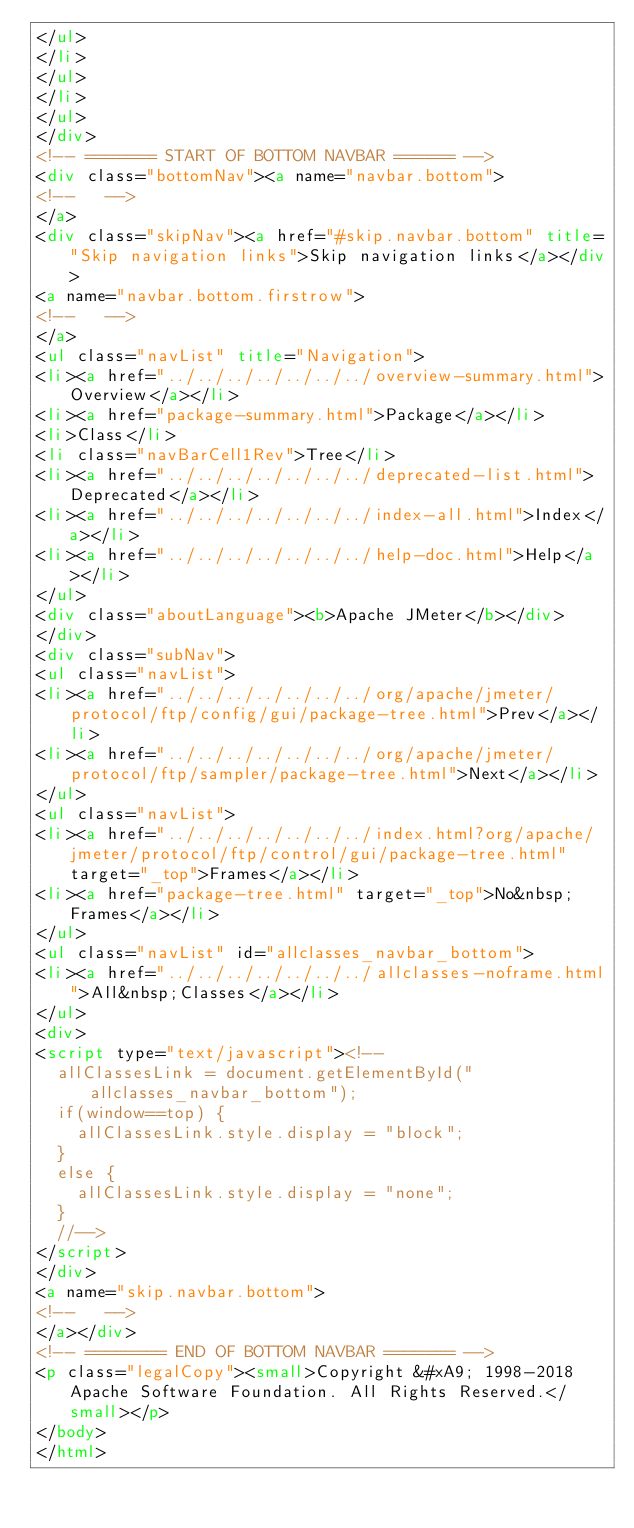<code> <loc_0><loc_0><loc_500><loc_500><_HTML_></ul>
</li>
</ul>
</li>
</ul>
</div>
<!-- ======= START OF BOTTOM NAVBAR ====== -->
<div class="bottomNav"><a name="navbar.bottom">
<!--   -->
</a>
<div class="skipNav"><a href="#skip.navbar.bottom" title="Skip navigation links">Skip navigation links</a></div>
<a name="navbar.bottom.firstrow">
<!--   -->
</a>
<ul class="navList" title="Navigation">
<li><a href="../../../../../../../overview-summary.html">Overview</a></li>
<li><a href="package-summary.html">Package</a></li>
<li>Class</li>
<li class="navBarCell1Rev">Tree</li>
<li><a href="../../../../../../../deprecated-list.html">Deprecated</a></li>
<li><a href="../../../../../../../index-all.html">Index</a></li>
<li><a href="../../../../../../../help-doc.html">Help</a></li>
</ul>
<div class="aboutLanguage"><b>Apache JMeter</b></div>
</div>
<div class="subNav">
<ul class="navList">
<li><a href="../../../../../../../org/apache/jmeter/protocol/ftp/config/gui/package-tree.html">Prev</a></li>
<li><a href="../../../../../../../org/apache/jmeter/protocol/ftp/sampler/package-tree.html">Next</a></li>
</ul>
<ul class="navList">
<li><a href="../../../../../../../index.html?org/apache/jmeter/protocol/ftp/control/gui/package-tree.html" target="_top">Frames</a></li>
<li><a href="package-tree.html" target="_top">No&nbsp;Frames</a></li>
</ul>
<ul class="navList" id="allclasses_navbar_bottom">
<li><a href="../../../../../../../allclasses-noframe.html">All&nbsp;Classes</a></li>
</ul>
<div>
<script type="text/javascript"><!--
  allClassesLink = document.getElementById("allclasses_navbar_bottom");
  if(window==top) {
    allClassesLink.style.display = "block";
  }
  else {
    allClassesLink.style.display = "none";
  }
  //-->
</script>
</div>
<a name="skip.navbar.bottom">
<!--   -->
</a></div>
<!-- ======== END OF BOTTOM NAVBAR ======= -->
<p class="legalCopy"><small>Copyright &#xA9; 1998-2018 Apache Software Foundation. All Rights Reserved.</small></p>
</body>
</html>
</code> 